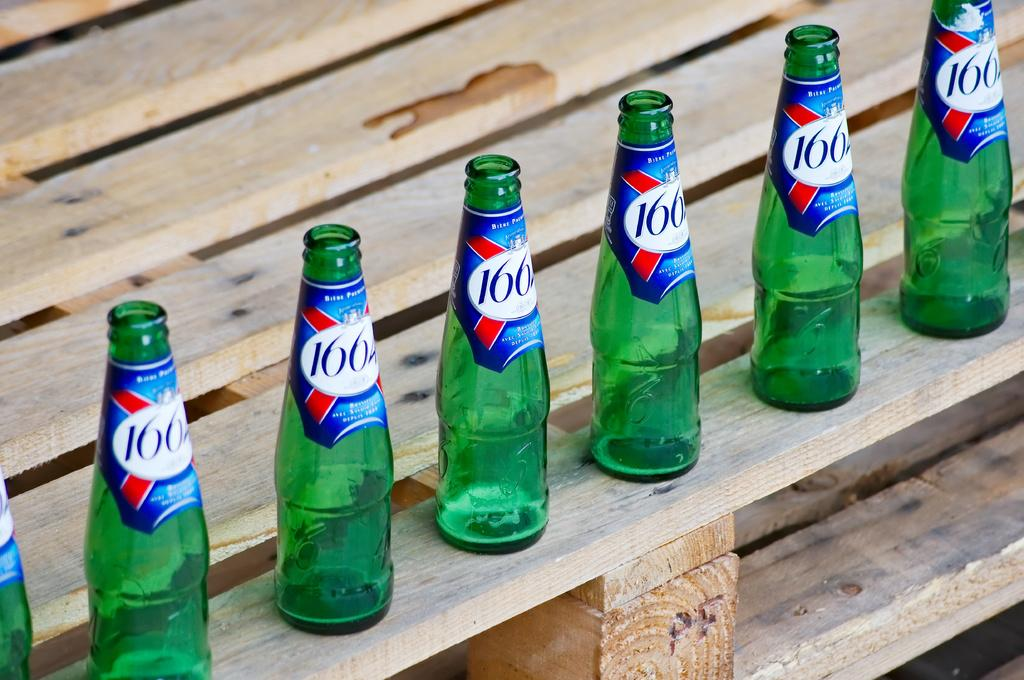<image>
Create a compact narrative representing the image presented. a row of green bottles on a deck that are labeled '1662' 